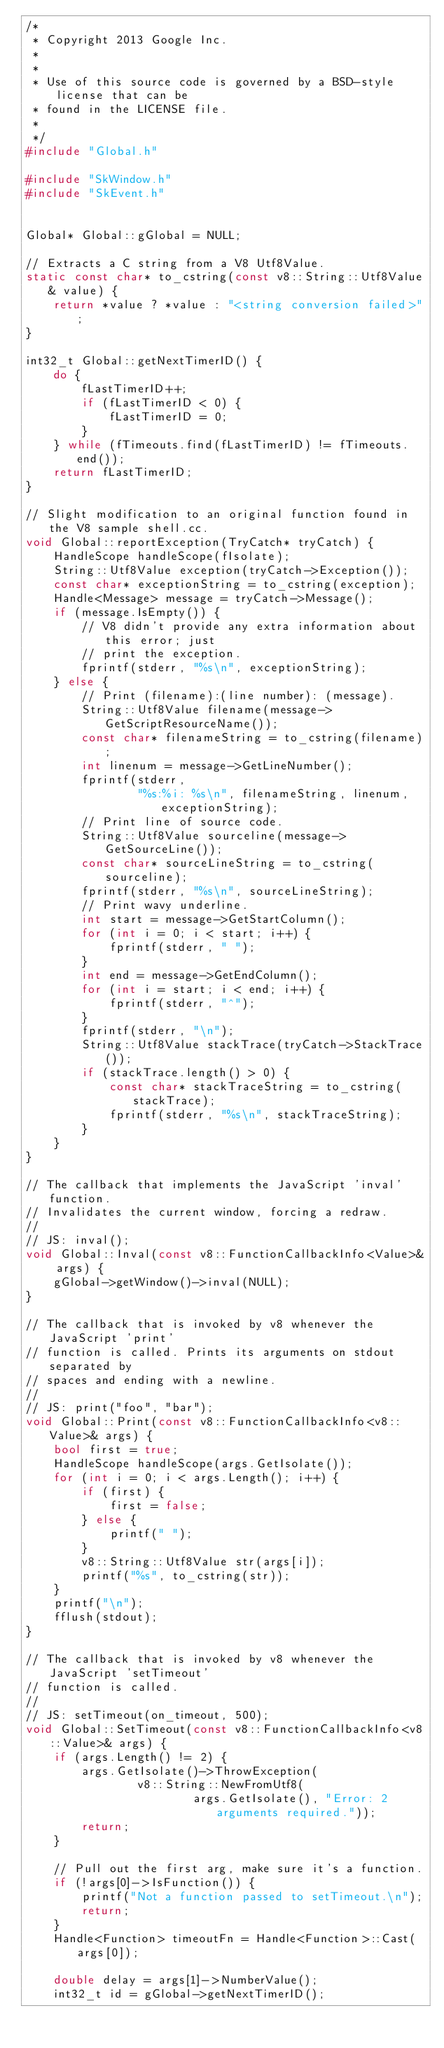<code> <loc_0><loc_0><loc_500><loc_500><_C++_>/*
 * Copyright 2013 Google Inc.
 *
 *
 * Use of this source code is governed by a BSD-style license that can be
 * found in the LICENSE file.
 *
 */
#include "Global.h"

#include "SkWindow.h"
#include "SkEvent.h"


Global* Global::gGlobal = NULL;

// Extracts a C string from a V8 Utf8Value.
static const char* to_cstring(const v8::String::Utf8Value& value) {
    return *value ? *value : "<string conversion failed>";
}

int32_t Global::getNextTimerID() {
    do {
        fLastTimerID++;
        if (fLastTimerID < 0) {
            fLastTimerID = 0;
        }
    } while (fTimeouts.find(fLastTimerID) != fTimeouts.end());
    return fLastTimerID;
}

// Slight modification to an original function found in the V8 sample shell.cc.
void Global::reportException(TryCatch* tryCatch) {
    HandleScope handleScope(fIsolate);
    String::Utf8Value exception(tryCatch->Exception());
    const char* exceptionString = to_cstring(exception);
    Handle<Message> message = tryCatch->Message();
    if (message.IsEmpty()) {
        // V8 didn't provide any extra information about this error; just
        // print the exception.
        fprintf(stderr, "%s\n", exceptionString);
    } else {
        // Print (filename):(line number): (message).
        String::Utf8Value filename(message->GetScriptResourceName());
        const char* filenameString = to_cstring(filename);
        int linenum = message->GetLineNumber();
        fprintf(stderr,
                "%s:%i: %s\n", filenameString, linenum, exceptionString);
        // Print line of source code.
        String::Utf8Value sourceline(message->GetSourceLine());
        const char* sourceLineString = to_cstring(sourceline);
        fprintf(stderr, "%s\n", sourceLineString);
        // Print wavy underline.
        int start = message->GetStartColumn();
        for (int i = 0; i < start; i++) {
            fprintf(stderr, " ");
        }
        int end = message->GetEndColumn();
        for (int i = start; i < end; i++) {
            fprintf(stderr, "^");
        }
        fprintf(stderr, "\n");
        String::Utf8Value stackTrace(tryCatch->StackTrace());
        if (stackTrace.length() > 0) {
            const char* stackTraceString = to_cstring(stackTrace);
            fprintf(stderr, "%s\n", stackTraceString);
        }
    }
}

// The callback that implements the JavaScript 'inval' function.
// Invalidates the current window, forcing a redraw.
//
// JS: inval();
void Global::Inval(const v8::FunctionCallbackInfo<Value>& args) {
    gGlobal->getWindow()->inval(NULL);
}

// The callback that is invoked by v8 whenever the JavaScript 'print'
// function is called. Prints its arguments on stdout separated by
// spaces and ending with a newline.
//
// JS: print("foo", "bar");
void Global::Print(const v8::FunctionCallbackInfo<v8::Value>& args) {
    bool first = true;
    HandleScope handleScope(args.GetIsolate());
    for (int i = 0; i < args.Length(); i++) {
        if (first) {
            first = false;
        } else {
            printf(" ");
        }
        v8::String::Utf8Value str(args[i]);
        printf("%s", to_cstring(str));
    }
    printf("\n");
    fflush(stdout);
}

// The callback that is invoked by v8 whenever the JavaScript 'setTimeout'
// function is called.
//
// JS: setTimeout(on_timeout, 500);
void Global::SetTimeout(const v8::FunctionCallbackInfo<v8::Value>& args) {
    if (args.Length() != 2) {
        args.GetIsolate()->ThrowException(
                v8::String::NewFromUtf8(
                        args.GetIsolate(), "Error: 2 arguments required."));
        return;
    }

    // Pull out the first arg, make sure it's a function.
    if (!args[0]->IsFunction()) {
        printf("Not a function passed to setTimeout.\n");
        return;
    }
    Handle<Function> timeoutFn = Handle<Function>::Cast(args[0]);

    double delay = args[1]->NumberValue();
    int32_t id = gGlobal->getNextTimerID();
</code> 